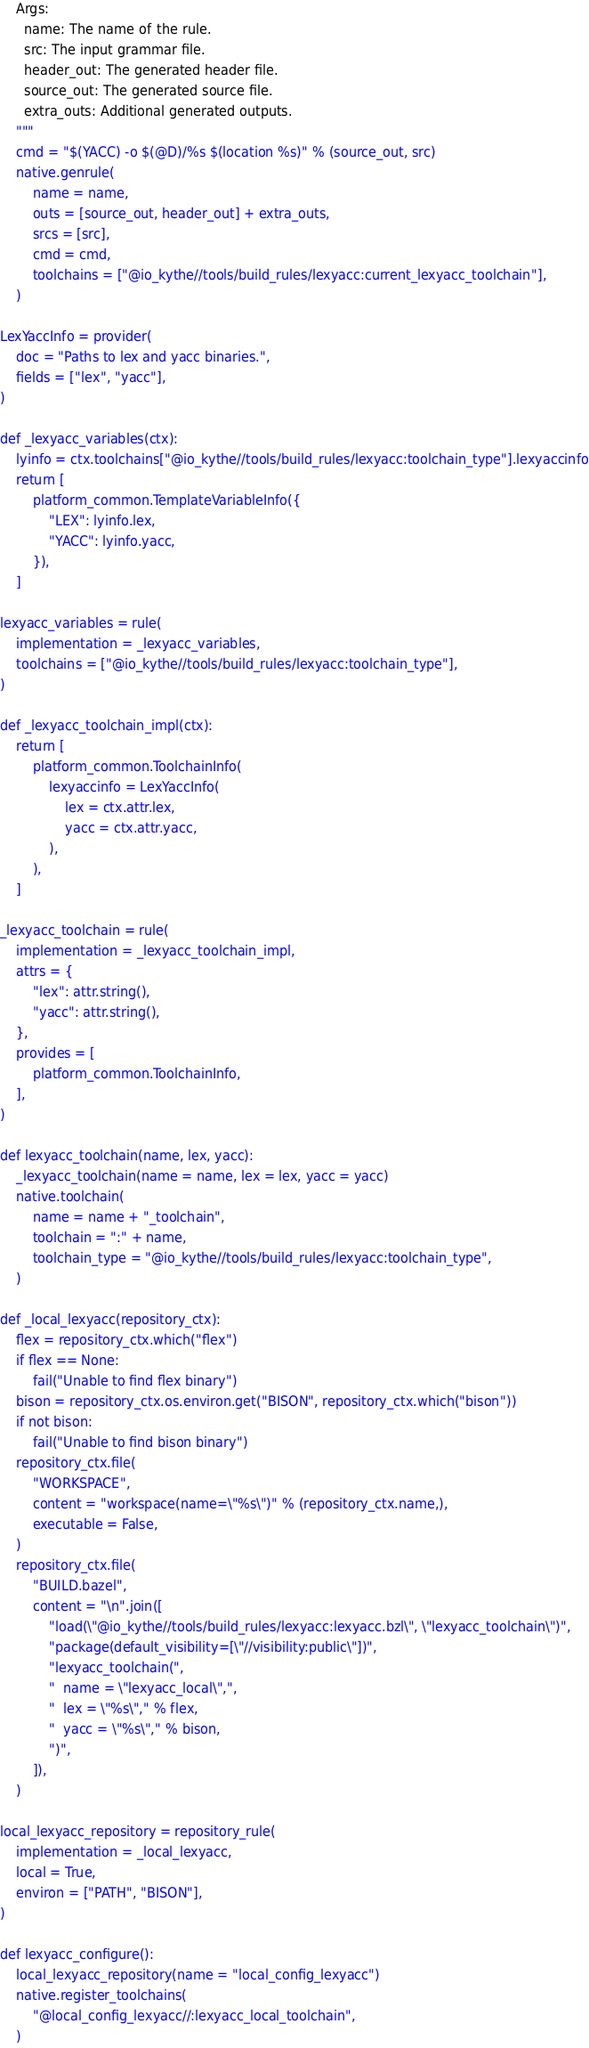<code> <loc_0><loc_0><loc_500><loc_500><_Python_>    Args:
      name: The name of the rule.
      src: The input grammar file.
      header_out: The generated header file.
      source_out: The generated source file.
      extra_outs: Additional generated outputs.
    """
    cmd = "$(YACC) -o $(@D)/%s $(location %s)" % (source_out, src)
    native.genrule(
        name = name,
        outs = [source_out, header_out] + extra_outs,
        srcs = [src],
        cmd = cmd,
        toolchains = ["@io_kythe//tools/build_rules/lexyacc:current_lexyacc_toolchain"],
    )

LexYaccInfo = provider(
    doc = "Paths to lex and yacc binaries.",
    fields = ["lex", "yacc"],
)

def _lexyacc_variables(ctx):
    lyinfo = ctx.toolchains["@io_kythe//tools/build_rules/lexyacc:toolchain_type"].lexyaccinfo
    return [
        platform_common.TemplateVariableInfo({
            "LEX": lyinfo.lex,
            "YACC": lyinfo.yacc,
        }),
    ]

lexyacc_variables = rule(
    implementation = _lexyacc_variables,
    toolchains = ["@io_kythe//tools/build_rules/lexyacc:toolchain_type"],
)

def _lexyacc_toolchain_impl(ctx):
    return [
        platform_common.ToolchainInfo(
            lexyaccinfo = LexYaccInfo(
                lex = ctx.attr.lex,
                yacc = ctx.attr.yacc,
            ),
        ),
    ]

_lexyacc_toolchain = rule(
    implementation = _lexyacc_toolchain_impl,
    attrs = {
        "lex": attr.string(),
        "yacc": attr.string(),
    },
    provides = [
        platform_common.ToolchainInfo,
    ],
)

def lexyacc_toolchain(name, lex, yacc):
    _lexyacc_toolchain(name = name, lex = lex, yacc = yacc)
    native.toolchain(
        name = name + "_toolchain",
        toolchain = ":" + name,
        toolchain_type = "@io_kythe//tools/build_rules/lexyacc:toolchain_type",
    )

def _local_lexyacc(repository_ctx):
    flex = repository_ctx.which("flex")
    if flex == None:
        fail("Unable to find flex binary")
    bison = repository_ctx.os.environ.get("BISON", repository_ctx.which("bison"))
    if not bison:
        fail("Unable to find bison binary")
    repository_ctx.file(
        "WORKSPACE",
        content = "workspace(name=\"%s\")" % (repository_ctx.name,),
        executable = False,
    )
    repository_ctx.file(
        "BUILD.bazel",
        content = "\n".join([
            "load(\"@io_kythe//tools/build_rules/lexyacc:lexyacc.bzl\", \"lexyacc_toolchain\")",
            "package(default_visibility=[\"//visibility:public\"])",
            "lexyacc_toolchain(",
            "  name = \"lexyacc_local\",",
            "  lex = \"%s\"," % flex,
            "  yacc = \"%s\"," % bison,
            ")",
        ]),
    )

local_lexyacc_repository = repository_rule(
    implementation = _local_lexyacc,
    local = True,
    environ = ["PATH", "BISON"],
)

def lexyacc_configure():
    local_lexyacc_repository(name = "local_config_lexyacc")
    native.register_toolchains(
        "@local_config_lexyacc//:lexyacc_local_toolchain",
    )
</code> 